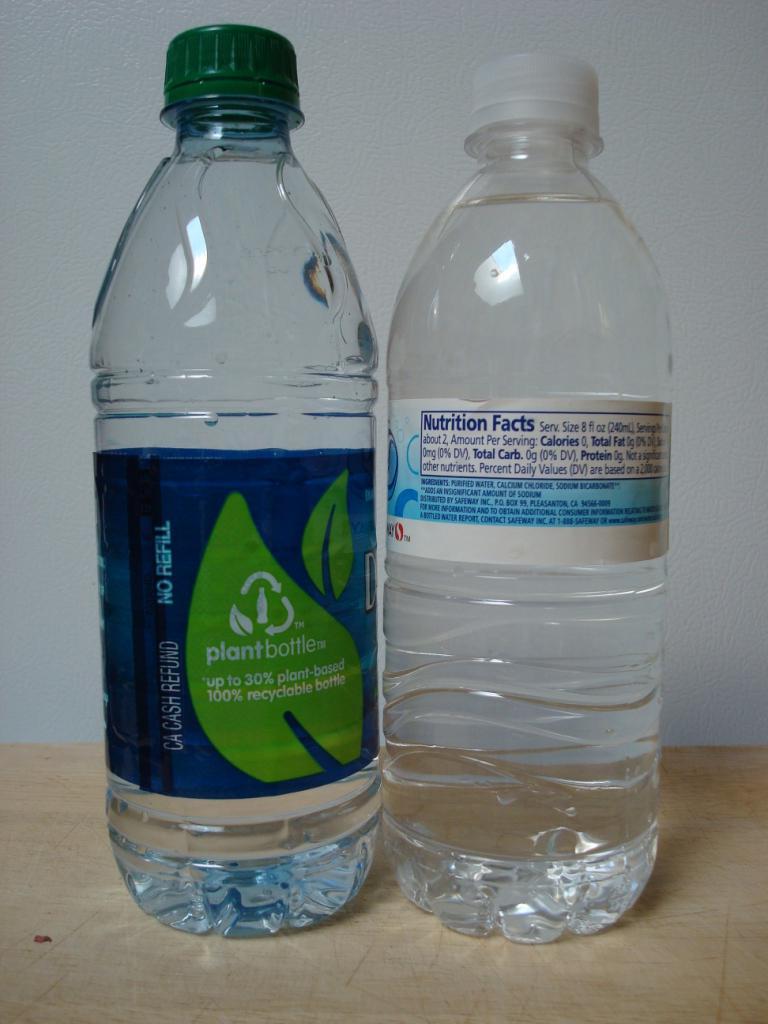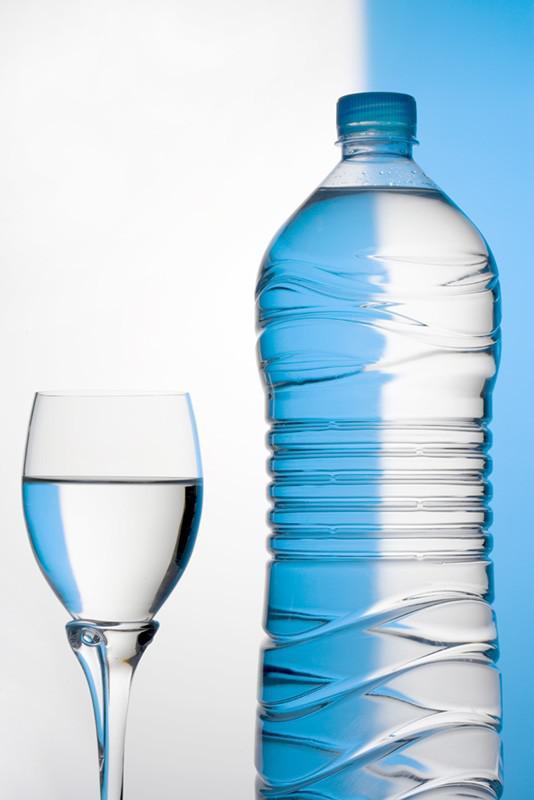The first image is the image on the left, the second image is the image on the right. Analyze the images presented: Is the assertion "There are three or more plastic water bottles in total." valid? Answer yes or no. Yes. 